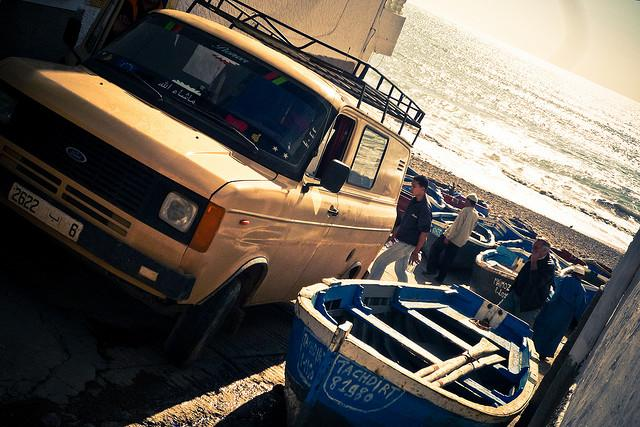What are the first two numbers on the truck? two six 